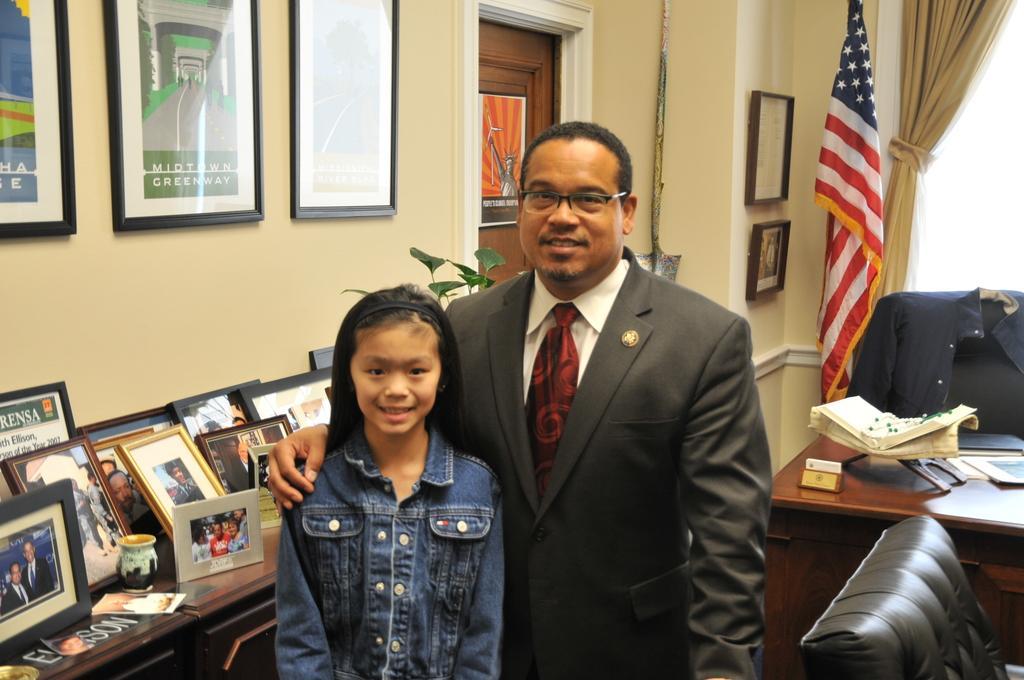Could you give a brief overview of what you see in this image? On the background we can see photo frames over a wall. This is a door and poster. this is a flag. We can see a window and a curtain here. On the table we can see a book, photo frames and a mug. Here we can see one man standing and he laid his hand on a girl's shoulder. There is a coat over a chair. At the right side of the picture we can see empty chair. 